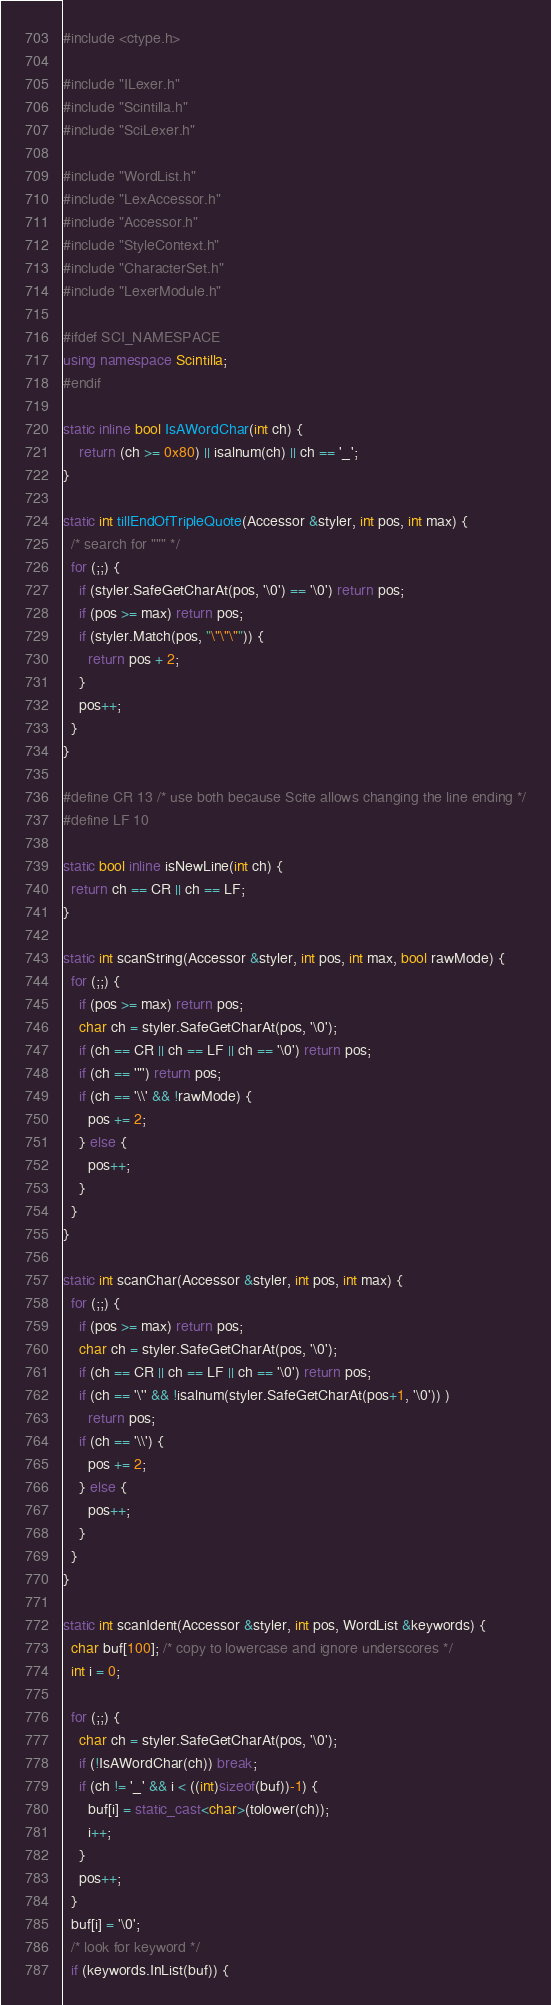<code> <loc_0><loc_0><loc_500><loc_500><_C++_>#include <ctype.h>

#include "ILexer.h"
#include "Scintilla.h"
#include "SciLexer.h"

#include "WordList.h"
#include "LexAccessor.h"
#include "Accessor.h"
#include "StyleContext.h"
#include "CharacterSet.h"
#include "LexerModule.h"

#ifdef SCI_NAMESPACE
using namespace Scintilla;
#endif

static inline bool IsAWordChar(int ch) {
	return (ch >= 0x80) || isalnum(ch) || ch == '_';
}

static int tillEndOfTripleQuote(Accessor &styler, int pos, int max) {
  /* search for """ */
  for (;;) {
    if (styler.SafeGetCharAt(pos, '\0') == '\0') return pos;
    if (pos >= max) return pos;
    if (styler.Match(pos, "\"\"\"")) {
      return pos + 2;
    }
    pos++;
  }
}

#define CR 13 /* use both because Scite allows changing the line ending */
#define LF 10

static bool inline isNewLine(int ch) {
  return ch == CR || ch == LF;
}

static int scanString(Accessor &styler, int pos, int max, bool rawMode) {
  for (;;) {
    if (pos >= max) return pos;
    char ch = styler.SafeGetCharAt(pos, '\0');
    if (ch == CR || ch == LF || ch == '\0') return pos;
    if (ch == '"') return pos;
    if (ch == '\\' && !rawMode) {
      pos += 2;
    } else {
      pos++;
    }
  }
}

static int scanChar(Accessor &styler, int pos, int max) {
  for (;;) {
    if (pos >= max) return pos;
    char ch = styler.SafeGetCharAt(pos, '\0');
    if (ch == CR || ch == LF || ch == '\0') return pos;
    if (ch == '\'' && !isalnum(styler.SafeGetCharAt(pos+1, '\0')) )
      return pos;
    if (ch == '\\') {
      pos += 2;
    } else {
      pos++;
    }
  }
}

static int scanIdent(Accessor &styler, int pos, WordList &keywords) {
  char buf[100]; /* copy to lowercase and ignore underscores */
  int i = 0;

  for (;;) {
    char ch = styler.SafeGetCharAt(pos, '\0');
    if (!IsAWordChar(ch)) break;
    if (ch != '_' && i < ((int)sizeof(buf))-1) {
      buf[i] = static_cast<char>(tolower(ch));
      i++;
    }
    pos++;
  }
  buf[i] = '\0';
  /* look for keyword */
  if (keywords.InList(buf)) {</code> 